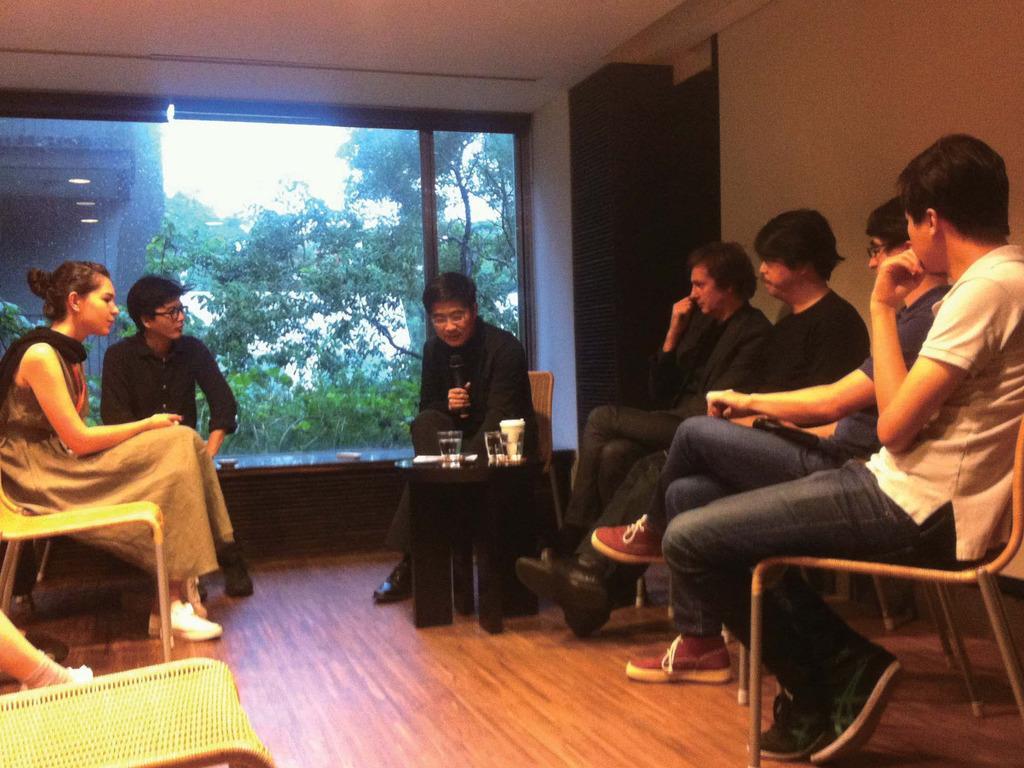Describe this image in one or two sentences. In this picture I can see few people are sitting in the chairs and I can see couple of glasses, a paper and a cup on the table and I can see a empty chair on the left side and from the window glass I can see trees and other building and I can see sky. 